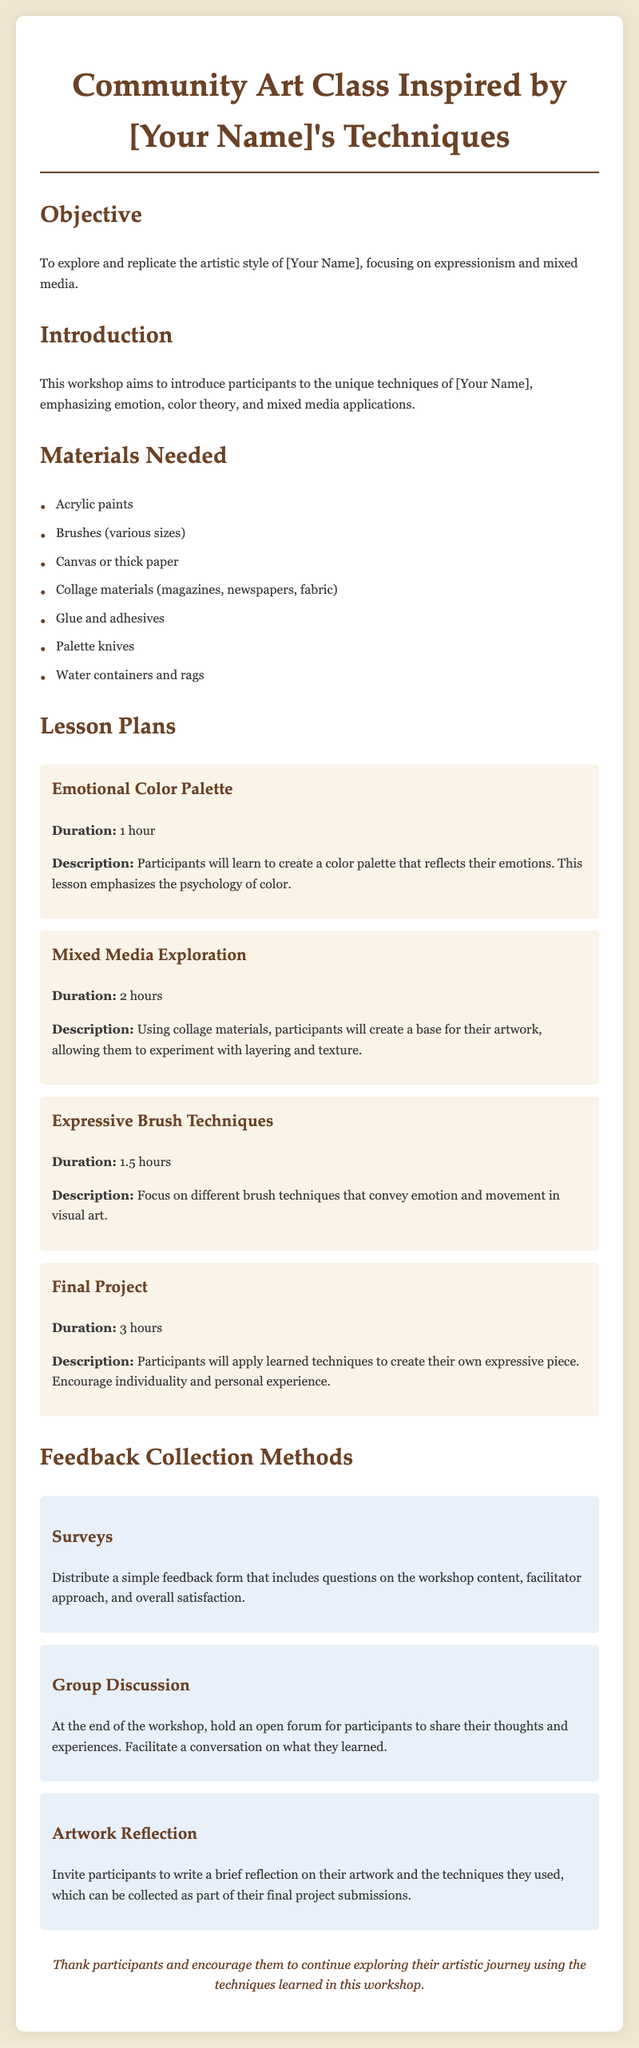what is the main objective of the workshop? The document states that the objective is to explore and replicate the artistic style of [Your Name], focusing on expressionism and mixed media.
Answer: explore and replicate the artistic style of [Your Name] how many lesson plans are included in the document? The document lists four distinct lesson plans for the workshop.
Answer: 4 what is the duration of the "Final Project" lesson? The "Final Project" lesson is detailed to have a duration of 3 hours.
Answer: 3 hours what materials are needed for the art class? The document outlines several materials required, including acrylic paints, brushes, and canvas.
Answer: Acrylic paints, brushes, canvas which feedback collection method involves an open forum? The document describes a feedback collection method termed "Group Discussion" that consists of an open forum for participants.
Answer: Group Discussion what is emphasized in the "Emotional Color Palette" lesson? The lesson emphasizes the psychology of color as part of the learning experience.
Answer: psychology of color how many hours is allocated for the "Mixed Media Exploration" lesson? The document indicates that the "Mixed Media Exploration" lesson has a duration of 2 hours.
Answer: 2 hours what is a key aspect participants will learn in the "Expressive Brush Techniques" lesson? Participants are taught different brush techniques that convey emotion and movement in visual art.
Answer: emotion and movement what is included in the feedback collection method "Artwork Reflection"? This method invites participants to write a brief reflection on their artwork and the techniques used.
Answer: write a brief reflection on their artwork 